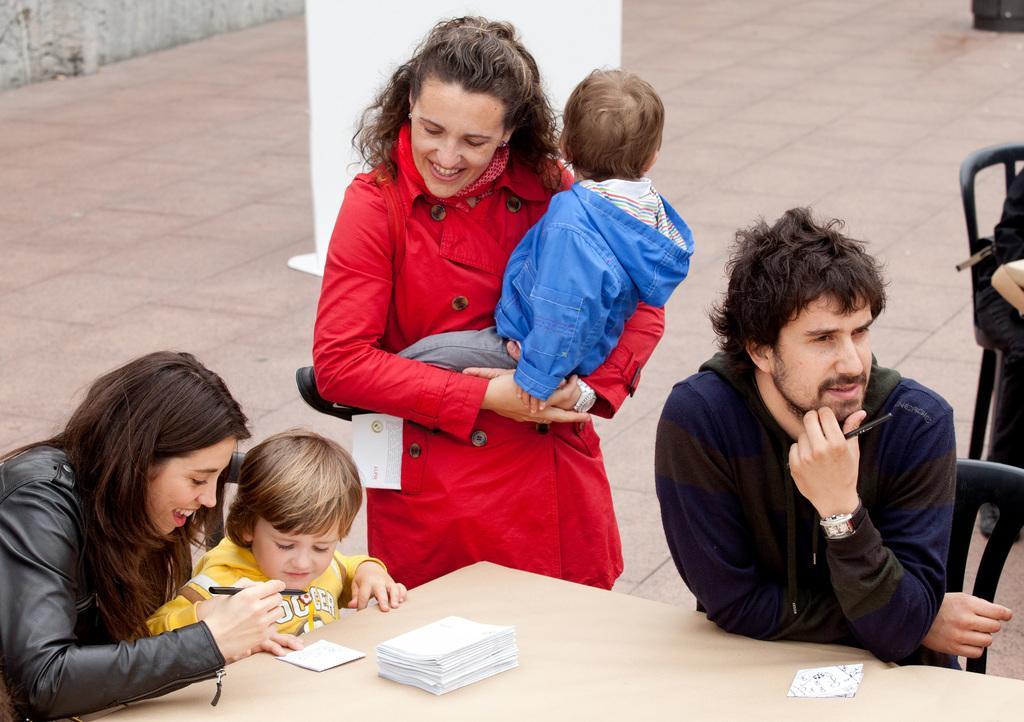Please provide a concise description of this image. people are sitting on the chairs. on the table there are papers. at the back there is a woman wearing red jacket 